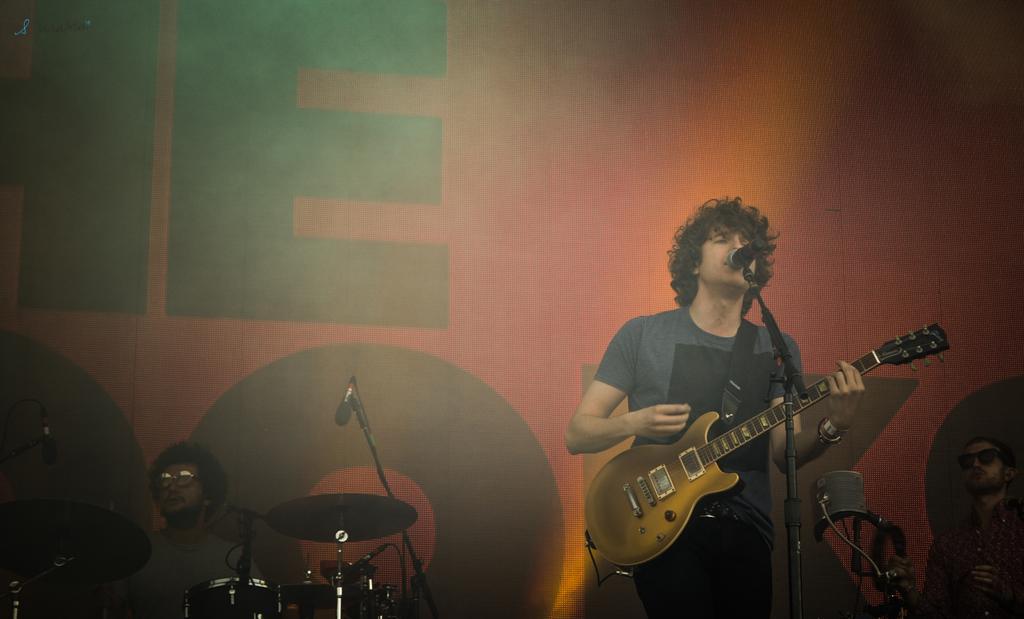Please provide a concise description of this image. This picture is clicked in a musical concert. Man in grey t-shirt is holding guitar in his hand and playing it. In front of him, we see a microphone and he is singing song on a microphone. Behind him, we see a man is playing drums and behind them, we see a sheet which is red in color. 